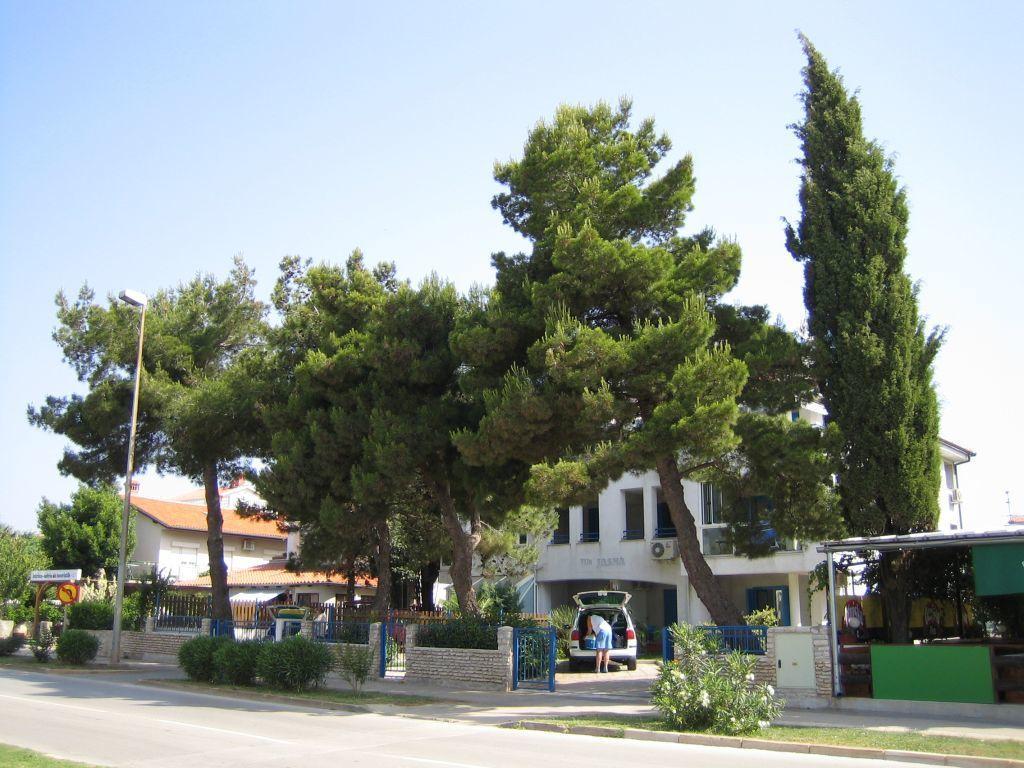Could you give a brief overview of what you see in this image? In this image I can see a road in the front. In the background I can see number of plants, few iron gates, few buildings, number of trees, a car, the sky and I can also see one person near the car. On the left side of the image I can see a white colour board, a pole, a street light and on the board I can see something is written. 